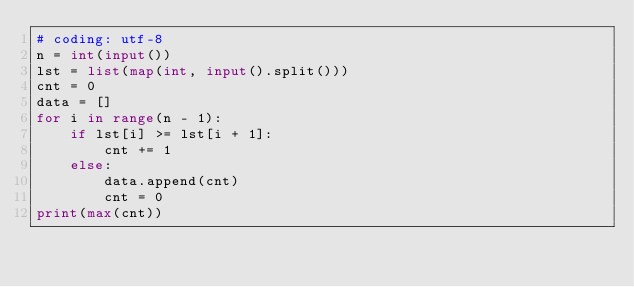<code> <loc_0><loc_0><loc_500><loc_500><_Python_># coding: utf-8
n = int(input())
lst = list(map(int, input().split()))
cnt = 0
data = []
for i in range(n - 1):
    if lst[i] >= lst[i + 1]:
        cnt += 1
    else:
        data.append(cnt)
        cnt = 0
print(max(cnt))
</code> 